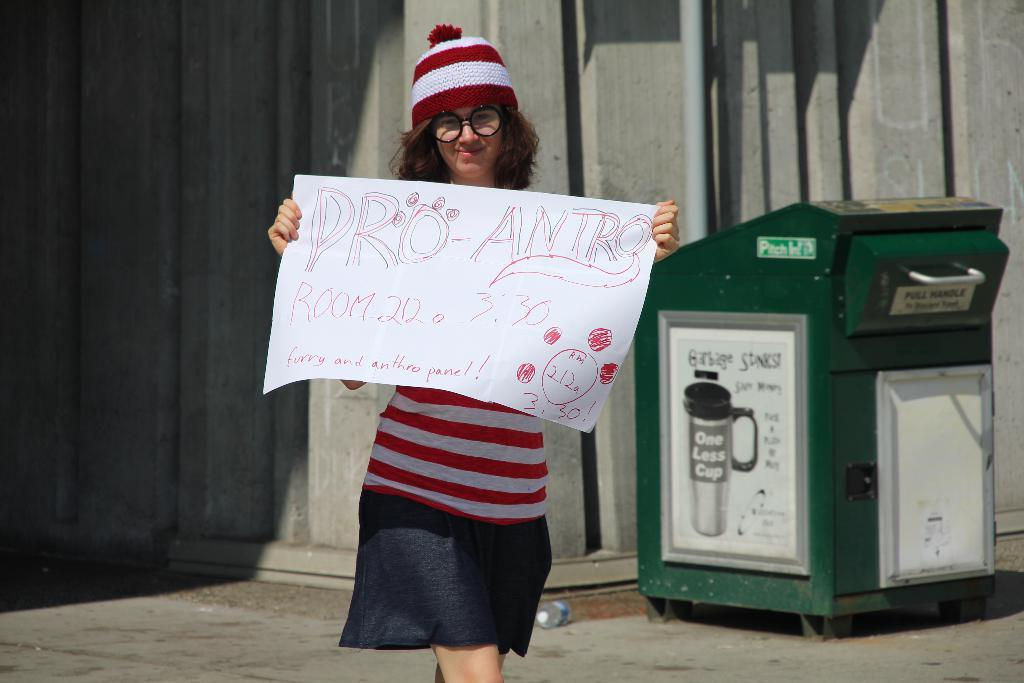Who is present in the image? There is a woman in the image. What is the woman holding? The woman is holding a poster. What can be seen in the background of the image? There is a wall, a pipe, and a box in the background of the image. Where was the image taken? The image was taken on a road. What type of stage can be seen in the background of the image? There is no stage present in the background of the image. Is the woman using a plough in the image? There is no plough present in the image. 